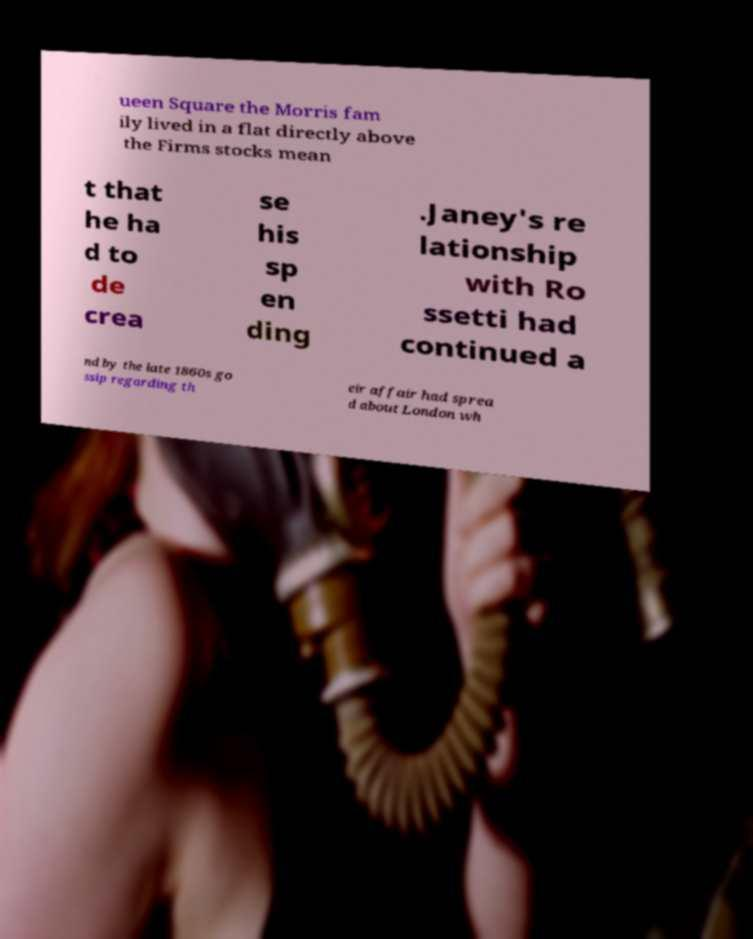Could you extract and type out the text from this image? ueen Square the Morris fam ily lived in a flat directly above the Firms stocks mean t that he ha d to de crea se his sp en ding .Janey's re lationship with Ro ssetti had continued a nd by the late 1860s go ssip regarding th eir affair had sprea d about London wh 